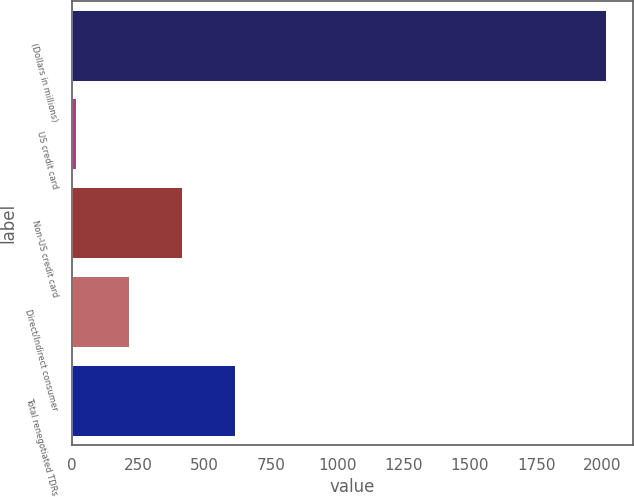<chart> <loc_0><loc_0><loc_500><loc_500><bar_chart><fcel>(Dollars in millions)<fcel>US credit card<fcel>Non-US credit card<fcel>Direct/Indirect consumer<fcel>Total renegotiated TDRs<nl><fcel>2013<fcel>16<fcel>415.4<fcel>215.7<fcel>615.1<nl></chart> 